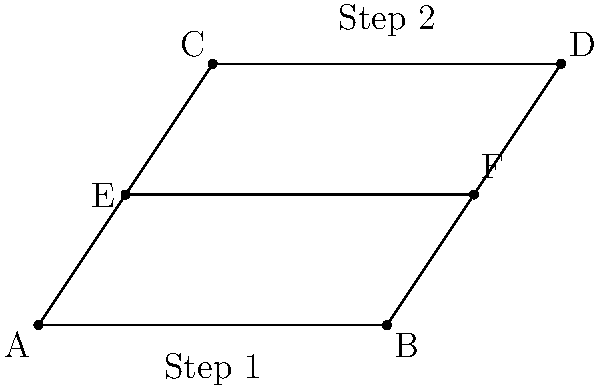In this simplified dance step diagram, two dancers move from positions A and B to positions C and D respectively. If segment EF represents their path at the midpoint of their dance, which of the following statements about congruent segments is true? Let's analyze the diagram step-by-step:

1) First, we note that the diagram forms a trapezoid ABDC, with EF as a line segment parallel to both AB and CD.

2) In a trapezoid, a line segment parallel to the bases divides the other two sides proportionally. This means that:
   $\frac{AE}{EC} = \frac{BF}{FD}$

3) Moreover, since EF is at the midpoint of the dance (which we can interpret as the midpoint of the trapezoid's height), we can conclude that:
   $AE = EC$ and $BF = FD$

4) This implies that E is the midpoint of AC, and F is the midpoint of BD.

5) In a trapezoid, the line segment joining the midpoints of the non-parallel sides is parallel to the bases and its length is equal to half the sum of the lengths of the bases. Therefore:
   $EF = \frac{1}{2}(AB + CD)$

6) Given that AB represents "Step 1" and CD represents "Step 2", we can conclude that EF is congruent to half the sum of these two steps.

Therefore, EF is congruent to half the sum of the lengths of AB and CD.
Answer: $EF \cong \frac{1}{2}(AB + CD)$ 